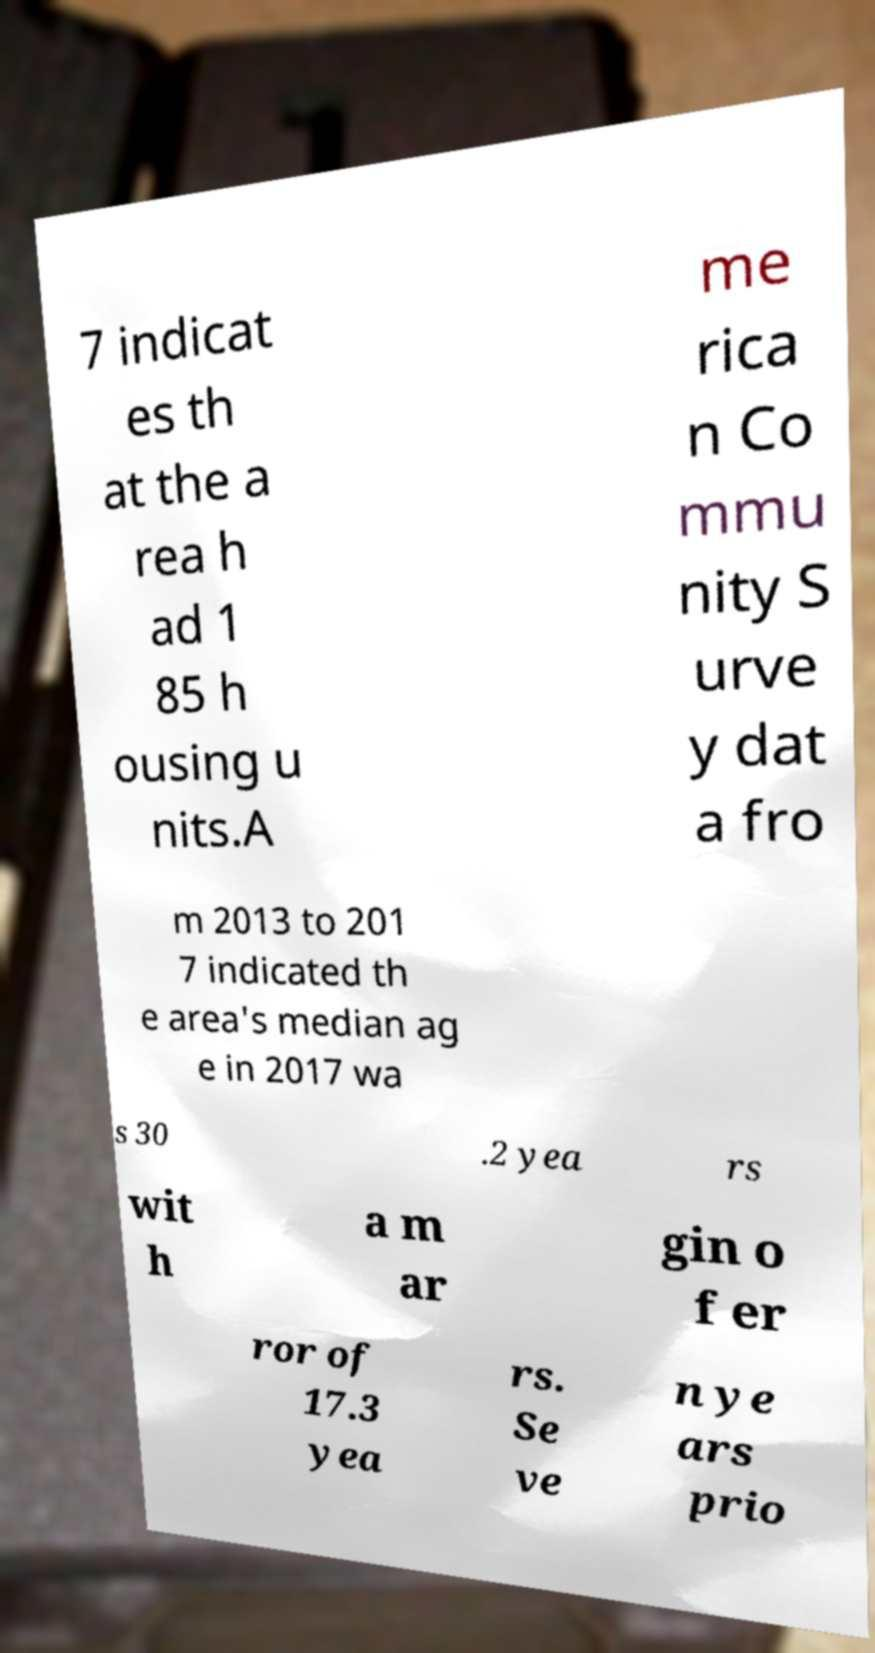For documentation purposes, I need the text within this image transcribed. Could you provide that? 7 indicat es th at the a rea h ad 1 85 h ousing u nits.A me rica n Co mmu nity S urve y dat a fro m 2013 to 201 7 indicated th e area's median ag e in 2017 wa s 30 .2 yea rs wit h a m ar gin o f er ror of 17.3 yea rs. Se ve n ye ars prio 